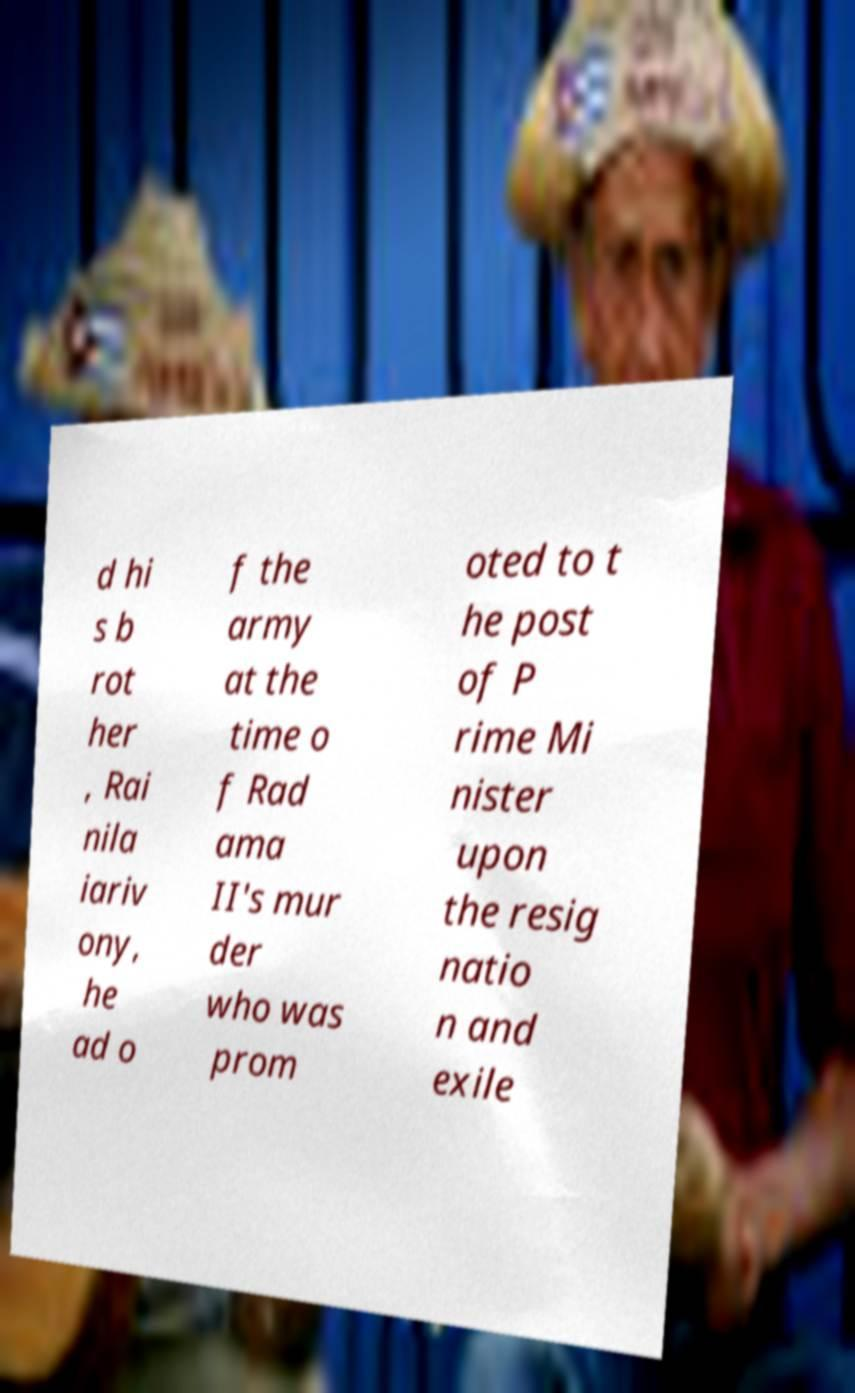Could you extract and type out the text from this image? d hi s b rot her , Rai nila iariv ony, he ad o f the army at the time o f Rad ama II's mur der who was prom oted to t he post of P rime Mi nister upon the resig natio n and exile 